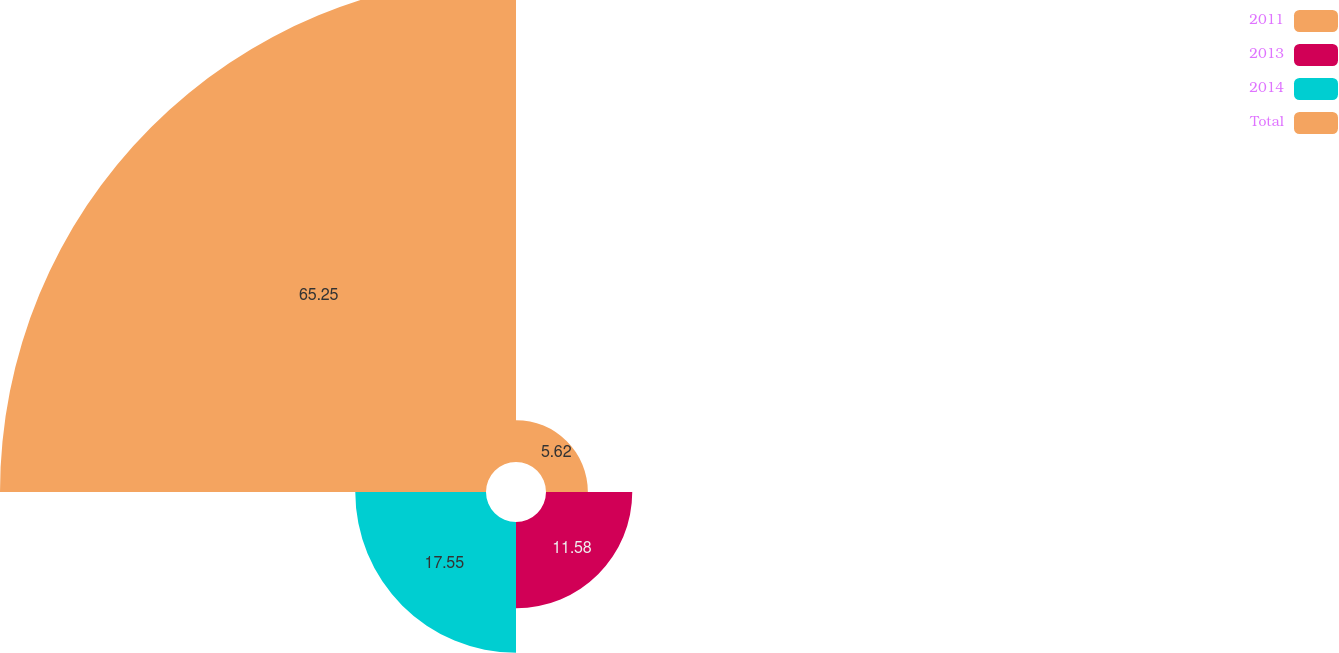<chart> <loc_0><loc_0><loc_500><loc_500><pie_chart><fcel>2011<fcel>2013<fcel>2014<fcel>Total<nl><fcel>5.62%<fcel>11.58%<fcel>17.55%<fcel>65.25%<nl></chart> 